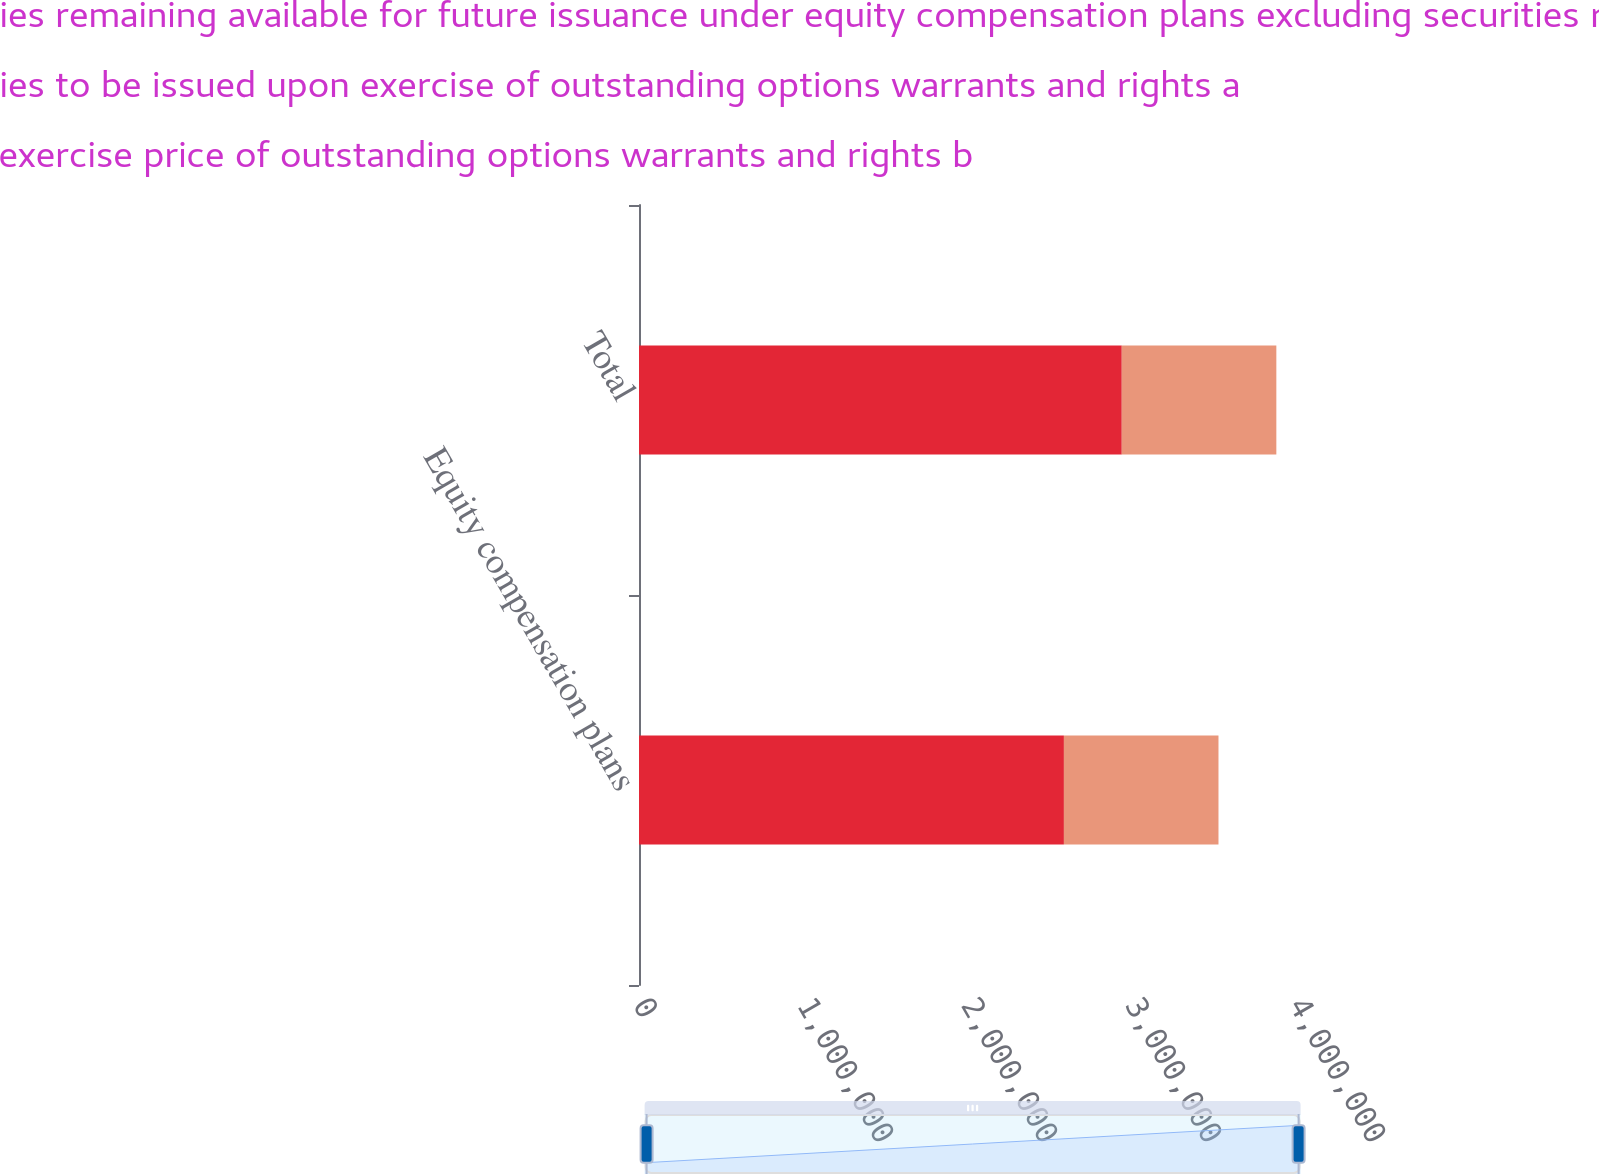<chart> <loc_0><loc_0><loc_500><loc_500><stacked_bar_chart><ecel><fcel>Equity compensation plans<fcel>Total<nl><fcel>Number of securities remaining available for future issuance under equity compensation plans excluding securities reflected in column a c<fcel>2.5909e+06<fcel>2.94369e+06<nl><fcel>Number of securities to be issued upon exercise of outstanding options warrants and rights a<fcel>22.08<fcel>20.31<nl><fcel>Weightedaverage exercise price of outstanding options warrants and rights b<fcel>942512<fcel>942512<nl></chart> 